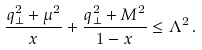Convert formula to latex. <formula><loc_0><loc_0><loc_500><loc_500>\frac { q _ { \perp } ^ { 2 } + \mu ^ { 2 } } { x } + \frac { q _ { \perp } ^ { 2 } + M ^ { 2 } } { 1 - x } \leq \Lambda ^ { 2 } \, .</formula> 